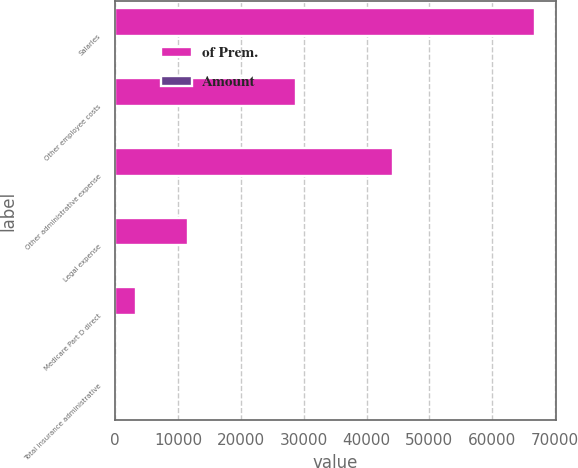Convert chart. <chart><loc_0><loc_0><loc_500><loc_500><stacked_bar_chart><ecel><fcel>Salaries<fcel>Other employee costs<fcel>Other administrative expense<fcel>Legal expense<fcel>Medicare Part D direct<fcel>Total insurance administrative<nl><fcel>of Prem.<fcel>66799<fcel>28709<fcel>44260<fcel>11513<fcel>3271<fcel>5.5<nl><fcel>Amount<fcel>2.4<fcel>1<fcel>1.6<fcel>0.4<fcel>0.1<fcel>5.5<nl></chart> 